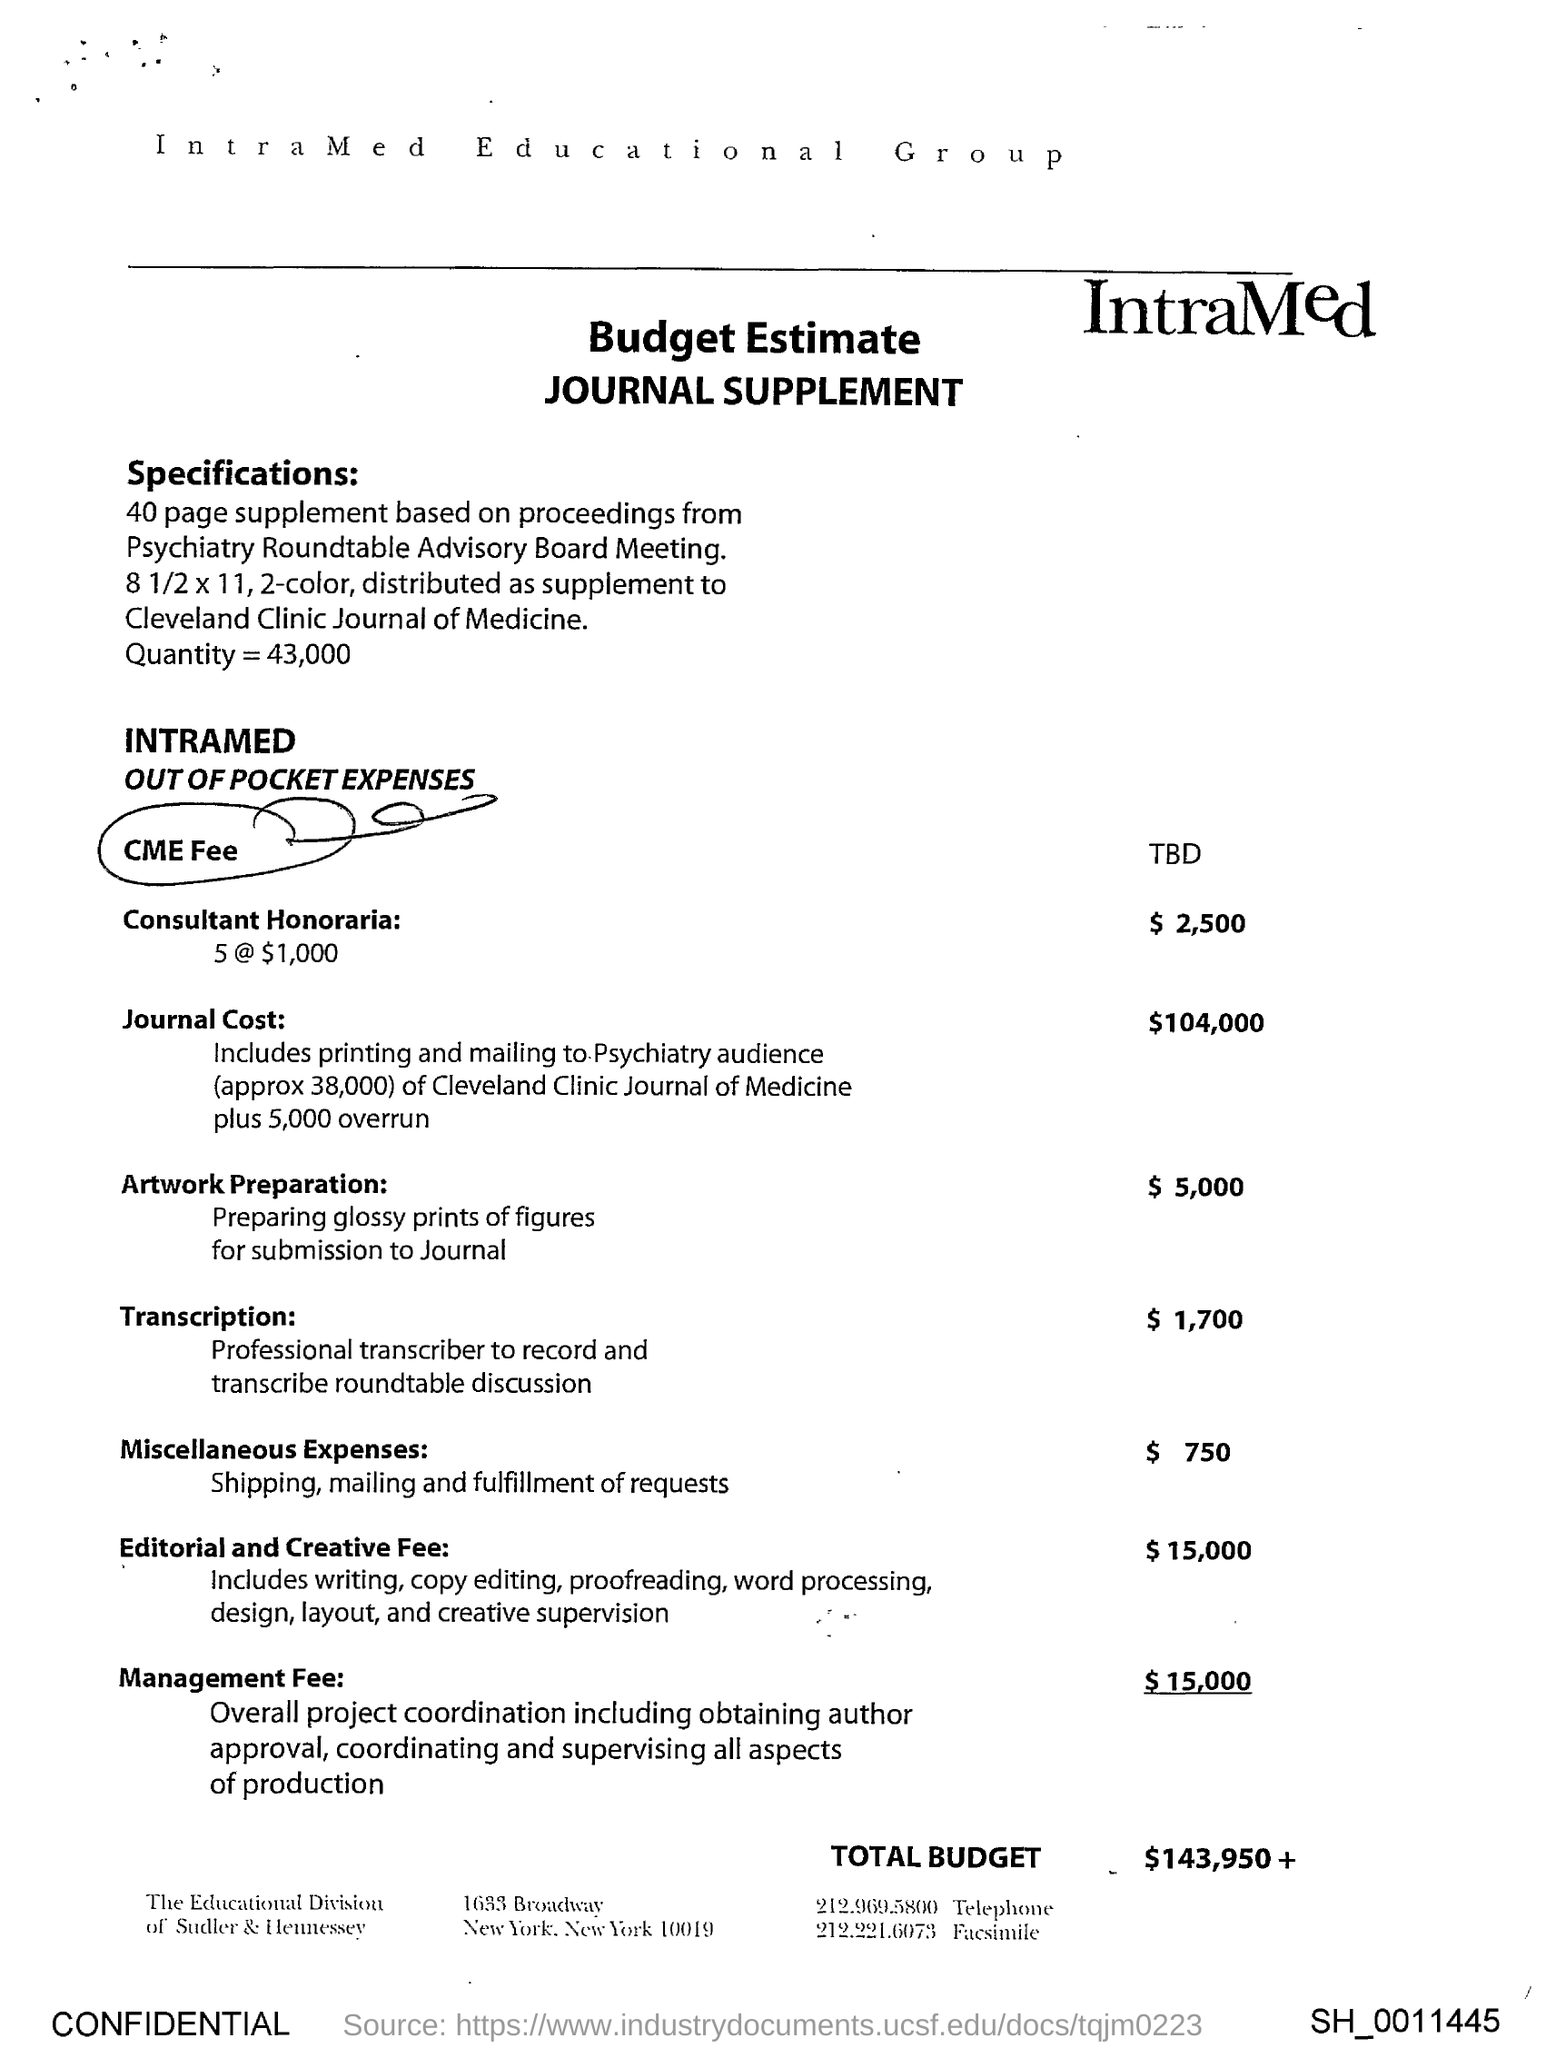Highlight a few significant elements in this photo. The Consultant Honoraria is $2,500. The journal cost is $104,000. The total budget for the project is $143,950 and will continue to increase as additional expenses are incurred. The CME fee has yet to be determined. The Editorial and Creative Fee is $15,000. 